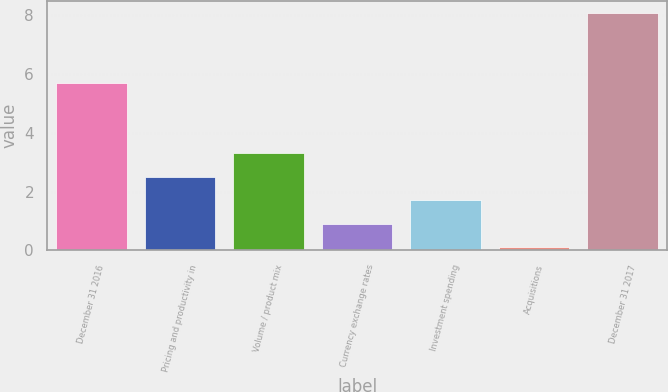<chart> <loc_0><loc_0><loc_500><loc_500><bar_chart><fcel>December 31 2016<fcel>Pricing and productivity in<fcel>Volume / product mix<fcel>Currency exchange rates<fcel>Investment spending<fcel>Acquisitions<fcel>December 31 2017<nl><fcel>5.7<fcel>2.5<fcel>3.3<fcel>0.9<fcel>1.7<fcel>0.1<fcel>8.1<nl></chart> 